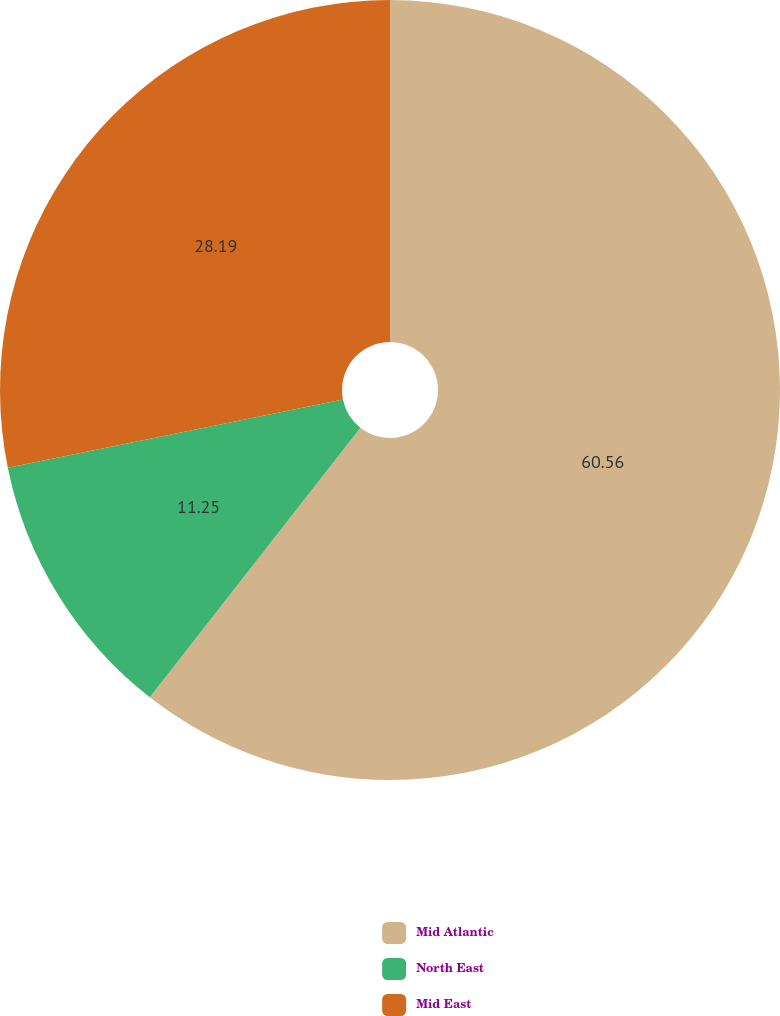<chart> <loc_0><loc_0><loc_500><loc_500><pie_chart><fcel>Mid Atlantic<fcel>North East<fcel>Mid East<nl><fcel>60.56%<fcel>11.25%<fcel>28.19%<nl></chart> 